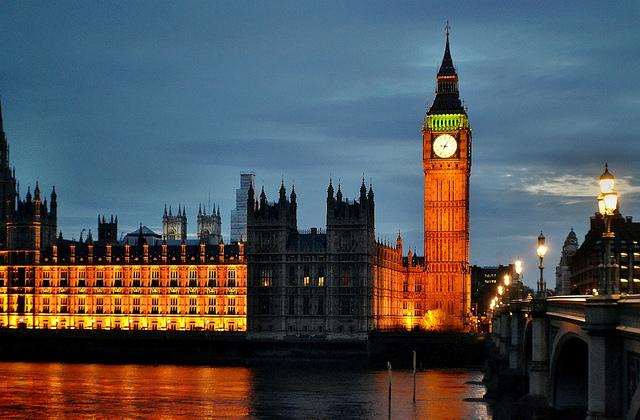Is this the Eiffel tower?
Give a very brief answer. No. Is it night time?
Answer briefly. Yes. What time is it?
Quick response, please. 9:05. 